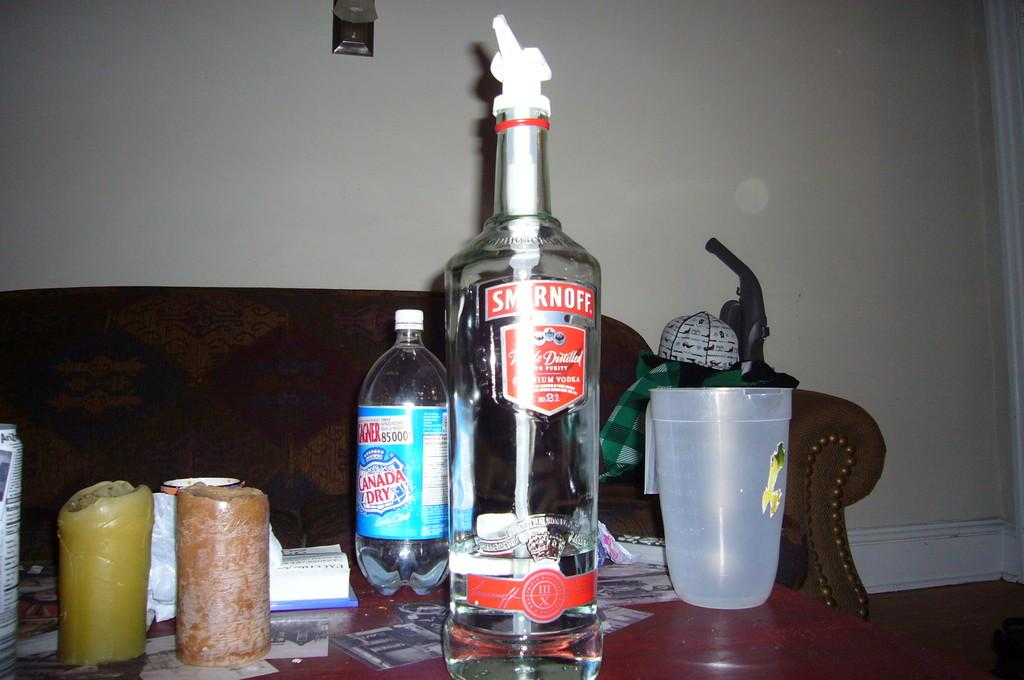<image>
Offer a succinct explanation of the picture presented. Empty Smirnoff bottle between a Canada dry and a cup. 